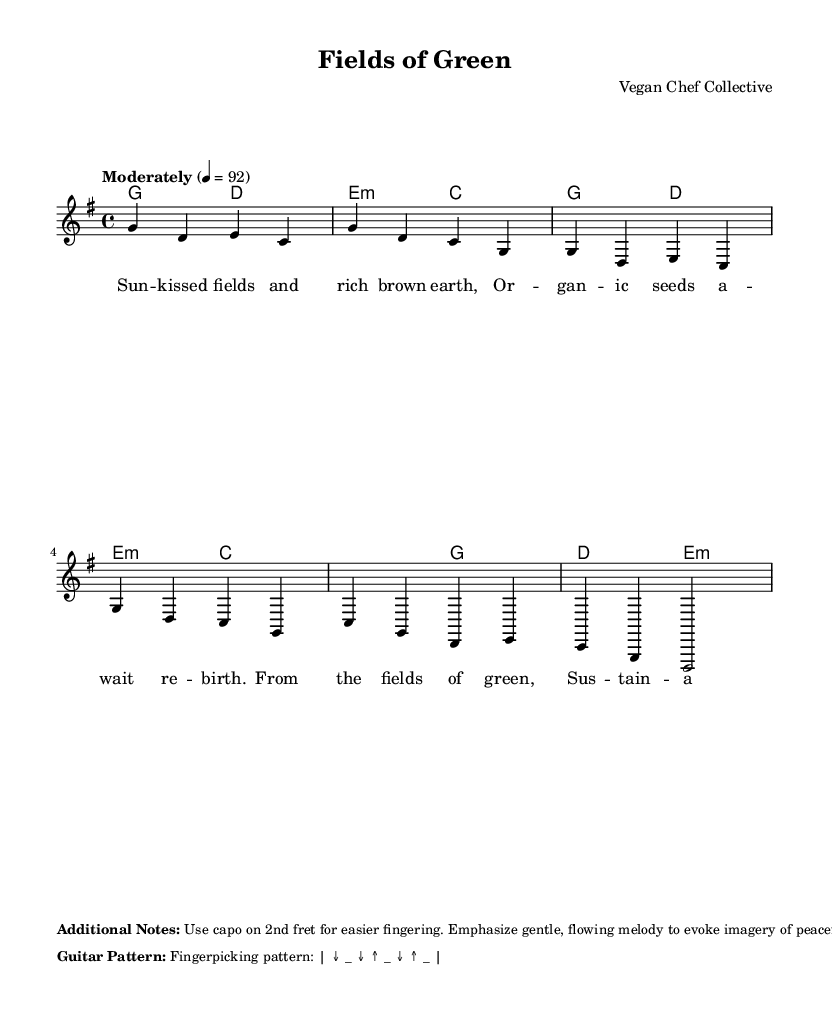What is the key signature of this music? The key signature is G major, which has one sharp (F#). This can be identified from the global section where the key is specified.
Answer: G major What is the time signature of this music? The time signature is 4/4, indicating four beats per measure. This is found in the global section of the sheet music where the time is clearly stated.
Answer: 4/4 What is the tempo marking for this piece? The tempo marking is "Moderately" set at 92 beats per minute, indicated in the global section of the music.
Answer: Moderately 92 How many chords are used in the chorus? The chorus features three chords: C, G, and D. A clear review of the harmonies section in the music shows the distinct chords used there.
Answer: Three What is the primary theme of the lyrics? The primary theme of the lyrics revolves around sustainable farming and organic produce, as highlighted by the imagery depicted in the verse and chorus.
Answer: Sustainable farming What picking pattern is suggested for the guitar accompaniment? The suggested fingerpicking pattern is down, up, down, up, down, up, as indicated in the additional notes section of the sheet music.
Answer: Down, up, down, up, down, up What is the title of this piece? The title of the piece is "Fields of Green," which is stated in the header section of the music.
Answer: Fields of Green 